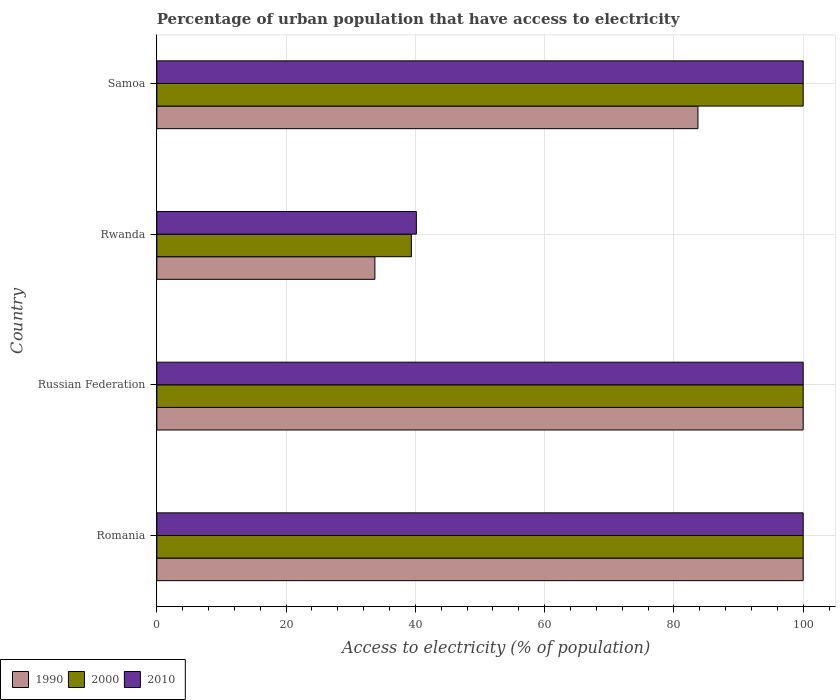How many groups of bars are there?
Keep it short and to the point. 4. How many bars are there on the 3rd tick from the bottom?
Offer a very short reply. 3. What is the label of the 4th group of bars from the top?
Ensure brevity in your answer.  Romania. Across all countries, what is the minimum percentage of urban population that have access to electricity in 1990?
Your response must be concise. 33.73. In which country was the percentage of urban population that have access to electricity in 1990 maximum?
Your answer should be very brief. Romania. In which country was the percentage of urban population that have access to electricity in 2010 minimum?
Offer a very short reply. Rwanda. What is the total percentage of urban population that have access to electricity in 2000 in the graph?
Your answer should be compact. 339.38. What is the difference between the percentage of urban population that have access to electricity in 1990 in Rwanda and that in Samoa?
Give a very brief answer. -49.98. What is the average percentage of urban population that have access to electricity in 2000 per country?
Give a very brief answer. 84.85. What is the difference between the percentage of urban population that have access to electricity in 2000 and percentage of urban population that have access to electricity in 1990 in Samoa?
Give a very brief answer. 16.28. What is the ratio of the percentage of urban population that have access to electricity in 2010 in Russian Federation to that in Samoa?
Keep it short and to the point. 1. Is the percentage of urban population that have access to electricity in 1990 in Rwanda less than that in Samoa?
Provide a short and direct response. Yes. Is the difference between the percentage of urban population that have access to electricity in 2000 in Russian Federation and Samoa greater than the difference between the percentage of urban population that have access to electricity in 1990 in Russian Federation and Samoa?
Keep it short and to the point. No. What is the difference between the highest and the second highest percentage of urban population that have access to electricity in 2010?
Make the answer very short. 0. What is the difference between the highest and the lowest percentage of urban population that have access to electricity in 1990?
Provide a succinct answer. 66.27. In how many countries, is the percentage of urban population that have access to electricity in 1990 greater than the average percentage of urban population that have access to electricity in 1990 taken over all countries?
Your answer should be compact. 3. What does the 3rd bar from the bottom in Samoa represents?
Offer a terse response. 2010. Are all the bars in the graph horizontal?
Give a very brief answer. Yes. How many countries are there in the graph?
Provide a short and direct response. 4. Does the graph contain any zero values?
Ensure brevity in your answer.  No. Does the graph contain grids?
Make the answer very short. Yes. What is the title of the graph?
Provide a short and direct response. Percentage of urban population that have access to electricity. Does "1984" appear as one of the legend labels in the graph?
Provide a succinct answer. No. What is the label or title of the X-axis?
Make the answer very short. Access to electricity (% of population). What is the Access to electricity (% of population) of 1990 in Romania?
Give a very brief answer. 100. What is the Access to electricity (% of population) in 2000 in Romania?
Provide a succinct answer. 100. What is the Access to electricity (% of population) in 1990 in Russian Federation?
Keep it short and to the point. 100. What is the Access to electricity (% of population) of 2000 in Russian Federation?
Your answer should be very brief. 100. What is the Access to electricity (% of population) of 1990 in Rwanda?
Keep it short and to the point. 33.73. What is the Access to electricity (% of population) in 2000 in Rwanda?
Provide a succinct answer. 39.38. What is the Access to electricity (% of population) of 2010 in Rwanda?
Keep it short and to the point. 40.15. What is the Access to electricity (% of population) of 1990 in Samoa?
Ensure brevity in your answer.  83.72. What is the Access to electricity (% of population) of 2000 in Samoa?
Offer a very short reply. 100. What is the Access to electricity (% of population) in 2010 in Samoa?
Your answer should be very brief. 100. Across all countries, what is the minimum Access to electricity (% of population) in 1990?
Make the answer very short. 33.73. Across all countries, what is the minimum Access to electricity (% of population) of 2000?
Keep it short and to the point. 39.38. Across all countries, what is the minimum Access to electricity (% of population) in 2010?
Keep it short and to the point. 40.15. What is the total Access to electricity (% of population) of 1990 in the graph?
Offer a terse response. 317.45. What is the total Access to electricity (% of population) of 2000 in the graph?
Ensure brevity in your answer.  339.38. What is the total Access to electricity (% of population) of 2010 in the graph?
Offer a very short reply. 340.15. What is the difference between the Access to electricity (% of population) in 1990 in Romania and that in Russian Federation?
Offer a very short reply. 0. What is the difference between the Access to electricity (% of population) in 1990 in Romania and that in Rwanda?
Ensure brevity in your answer.  66.27. What is the difference between the Access to electricity (% of population) of 2000 in Romania and that in Rwanda?
Ensure brevity in your answer.  60.62. What is the difference between the Access to electricity (% of population) in 2010 in Romania and that in Rwanda?
Provide a succinct answer. 59.85. What is the difference between the Access to electricity (% of population) of 1990 in Romania and that in Samoa?
Give a very brief answer. 16.28. What is the difference between the Access to electricity (% of population) in 1990 in Russian Federation and that in Rwanda?
Keep it short and to the point. 66.27. What is the difference between the Access to electricity (% of population) in 2000 in Russian Federation and that in Rwanda?
Your response must be concise. 60.62. What is the difference between the Access to electricity (% of population) in 2010 in Russian Federation and that in Rwanda?
Give a very brief answer. 59.85. What is the difference between the Access to electricity (% of population) of 1990 in Russian Federation and that in Samoa?
Give a very brief answer. 16.28. What is the difference between the Access to electricity (% of population) in 2000 in Russian Federation and that in Samoa?
Give a very brief answer. 0. What is the difference between the Access to electricity (% of population) in 1990 in Rwanda and that in Samoa?
Ensure brevity in your answer.  -49.98. What is the difference between the Access to electricity (% of population) in 2000 in Rwanda and that in Samoa?
Give a very brief answer. -60.62. What is the difference between the Access to electricity (% of population) of 2010 in Rwanda and that in Samoa?
Ensure brevity in your answer.  -59.85. What is the difference between the Access to electricity (% of population) of 1990 in Romania and the Access to electricity (% of population) of 2010 in Russian Federation?
Keep it short and to the point. 0. What is the difference between the Access to electricity (% of population) of 2000 in Romania and the Access to electricity (% of population) of 2010 in Russian Federation?
Your answer should be very brief. 0. What is the difference between the Access to electricity (% of population) of 1990 in Romania and the Access to electricity (% of population) of 2000 in Rwanda?
Offer a terse response. 60.62. What is the difference between the Access to electricity (% of population) of 1990 in Romania and the Access to electricity (% of population) of 2010 in Rwanda?
Your answer should be compact. 59.85. What is the difference between the Access to electricity (% of population) of 2000 in Romania and the Access to electricity (% of population) of 2010 in Rwanda?
Ensure brevity in your answer.  59.85. What is the difference between the Access to electricity (% of population) in 1990 in Romania and the Access to electricity (% of population) in 2000 in Samoa?
Make the answer very short. 0. What is the difference between the Access to electricity (% of population) of 1990 in Russian Federation and the Access to electricity (% of population) of 2000 in Rwanda?
Give a very brief answer. 60.62. What is the difference between the Access to electricity (% of population) in 1990 in Russian Federation and the Access to electricity (% of population) in 2010 in Rwanda?
Offer a terse response. 59.85. What is the difference between the Access to electricity (% of population) in 2000 in Russian Federation and the Access to electricity (% of population) in 2010 in Rwanda?
Ensure brevity in your answer.  59.85. What is the difference between the Access to electricity (% of population) of 1990 in Russian Federation and the Access to electricity (% of population) of 2000 in Samoa?
Offer a terse response. 0. What is the difference between the Access to electricity (% of population) in 1990 in Rwanda and the Access to electricity (% of population) in 2000 in Samoa?
Ensure brevity in your answer.  -66.27. What is the difference between the Access to electricity (% of population) in 1990 in Rwanda and the Access to electricity (% of population) in 2010 in Samoa?
Keep it short and to the point. -66.27. What is the difference between the Access to electricity (% of population) in 2000 in Rwanda and the Access to electricity (% of population) in 2010 in Samoa?
Offer a very short reply. -60.62. What is the average Access to electricity (% of population) of 1990 per country?
Keep it short and to the point. 79.36. What is the average Access to electricity (% of population) in 2000 per country?
Provide a succinct answer. 84.85. What is the average Access to electricity (% of population) in 2010 per country?
Make the answer very short. 85.04. What is the difference between the Access to electricity (% of population) in 1990 and Access to electricity (% of population) in 2000 in Romania?
Your response must be concise. 0. What is the difference between the Access to electricity (% of population) of 1990 and Access to electricity (% of population) of 2010 in Romania?
Offer a very short reply. 0. What is the difference between the Access to electricity (% of population) of 1990 and Access to electricity (% of population) of 2010 in Russian Federation?
Provide a short and direct response. 0. What is the difference between the Access to electricity (% of population) in 2000 and Access to electricity (% of population) in 2010 in Russian Federation?
Offer a very short reply. 0. What is the difference between the Access to electricity (% of population) of 1990 and Access to electricity (% of population) of 2000 in Rwanda?
Give a very brief answer. -5.65. What is the difference between the Access to electricity (% of population) of 1990 and Access to electricity (% of population) of 2010 in Rwanda?
Ensure brevity in your answer.  -6.42. What is the difference between the Access to electricity (% of population) in 2000 and Access to electricity (% of population) in 2010 in Rwanda?
Your answer should be compact. -0.77. What is the difference between the Access to electricity (% of population) of 1990 and Access to electricity (% of population) of 2000 in Samoa?
Provide a succinct answer. -16.28. What is the difference between the Access to electricity (% of population) in 1990 and Access to electricity (% of population) in 2010 in Samoa?
Make the answer very short. -16.28. What is the difference between the Access to electricity (% of population) in 2000 and Access to electricity (% of population) in 2010 in Samoa?
Offer a terse response. 0. What is the ratio of the Access to electricity (% of population) of 2000 in Romania to that in Russian Federation?
Offer a terse response. 1. What is the ratio of the Access to electricity (% of population) of 1990 in Romania to that in Rwanda?
Keep it short and to the point. 2.96. What is the ratio of the Access to electricity (% of population) in 2000 in Romania to that in Rwanda?
Provide a succinct answer. 2.54. What is the ratio of the Access to electricity (% of population) of 2010 in Romania to that in Rwanda?
Your answer should be very brief. 2.49. What is the ratio of the Access to electricity (% of population) in 1990 in Romania to that in Samoa?
Keep it short and to the point. 1.19. What is the ratio of the Access to electricity (% of population) in 2000 in Romania to that in Samoa?
Offer a terse response. 1. What is the ratio of the Access to electricity (% of population) in 1990 in Russian Federation to that in Rwanda?
Give a very brief answer. 2.96. What is the ratio of the Access to electricity (% of population) in 2000 in Russian Federation to that in Rwanda?
Keep it short and to the point. 2.54. What is the ratio of the Access to electricity (% of population) in 2010 in Russian Federation to that in Rwanda?
Make the answer very short. 2.49. What is the ratio of the Access to electricity (% of population) in 1990 in Russian Federation to that in Samoa?
Offer a very short reply. 1.19. What is the ratio of the Access to electricity (% of population) in 2000 in Russian Federation to that in Samoa?
Ensure brevity in your answer.  1. What is the ratio of the Access to electricity (% of population) in 1990 in Rwanda to that in Samoa?
Provide a succinct answer. 0.4. What is the ratio of the Access to electricity (% of population) in 2000 in Rwanda to that in Samoa?
Give a very brief answer. 0.39. What is the ratio of the Access to electricity (% of population) in 2010 in Rwanda to that in Samoa?
Offer a very short reply. 0.4. What is the difference between the highest and the second highest Access to electricity (% of population) of 2000?
Offer a very short reply. 0. What is the difference between the highest and the second highest Access to electricity (% of population) in 2010?
Your response must be concise. 0. What is the difference between the highest and the lowest Access to electricity (% of population) of 1990?
Provide a short and direct response. 66.27. What is the difference between the highest and the lowest Access to electricity (% of population) of 2000?
Keep it short and to the point. 60.62. What is the difference between the highest and the lowest Access to electricity (% of population) in 2010?
Make the answer very short. 59.85. 